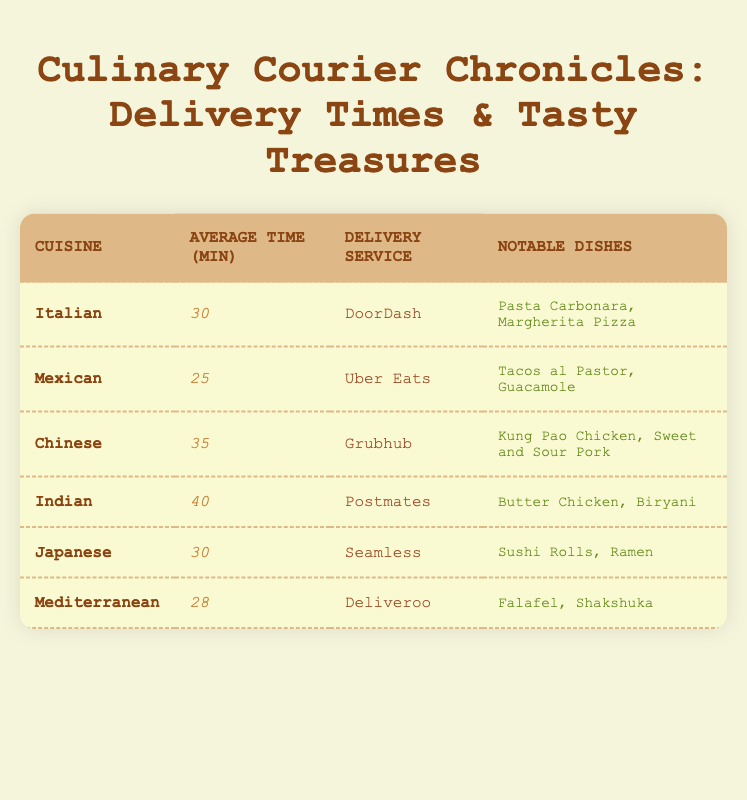What is the average delivery time for Mexican cuisine? The table shows that the average delivery time for Mexican cuisine is listed as 25 minutes.
Answer: 25 minutes Which delivery service is associated with Indian cuisine? According to the table, Indian cuisine is associated with the delivery service called Postmates.
Answer: Postmates What is the average delivery time across all types of cuisine listed in the table? The average delivery times for each cuisine are: Italian (30), Mexican (25), Chinese (35), Indian (40), Japanese (30), and Mediterranean (28). Adding these together (30 + 25 + 35 + 40 + 30 + 28) = 218, and then dividing by the number of cuisines (6) gives 218/6 = approximately 36.33.
Answer: Approximately 36.33 minutes Are Japanese dishes faster to deliver than Chinese dishes? The average delivery time for Japanese cuisine is 30 minutes, while for Chinese cuisine, it is 35 minutes. Since 30 is less than 35, Japanese dishes are indeed faster to deliver than Chinese dishes.
Answer: Yes Which cuisine has the longest average delivery time? By looking at the average delivery times listed, we see that Indian cuisine has the highest average time at 40 minutes.
Answer: Indian cuisine What is the sum of average delivery times for Italian and Mediterranean cuisines? The average delivery time for Italian cuisine is 30 minutes, and for Mediterranean, it is 28 minutes. Adding these (30 + 28) gives a total of 58 minutes.
Answer: 58 minutes Is it true that the notable dish for Italian cuisine is 'Butter Chicken'? The table indicates that notable dishes for Italian cuisine are Pasta Carbonara and Margherita Pizza, not Butter Chicken, which is an Indian dish. Therefore, this statement is false.
Answer: No Which cuisine takes less than 30 minutes on average for delivery? The table shows that only Mexican cuisine, which has an average delivery time of 25 minutes, takes less than 30 minutes on average.
Answer: Mexican cuisine What is the average delivery time difference between Indian and Mediterranean cuisines? The average delivery time for Indian cuisine is 40 minutes, while for Mediterranean cuisine, it is 28 minutes. The difference is calculated as 40 - 28 = 12 minutes.
Answer: 12 minutes 